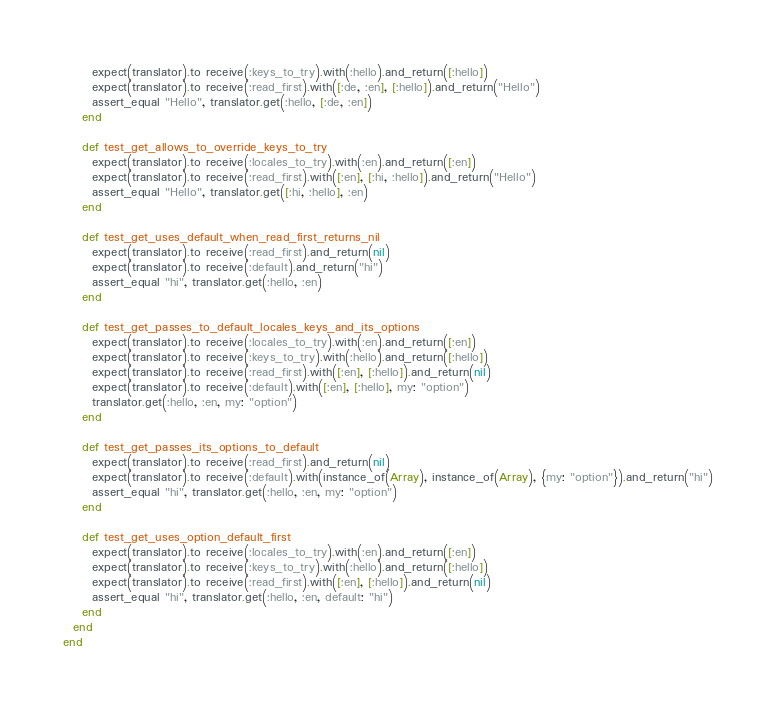<code> <loc_0><loc_0><loc_500><loc_500><_Ruby_>      expect(translator).to receive(:keys_to_try).with(:hello).and_return([:hello])
      expect(translator).to receive(:read_first).with([:de, :en], [:hello]).and_return("Hello")
      assert_equal "Hello", translator.get(:hello, [:de, :en])
    end

    def test_get_allows_to_override_keys_to_try
      expect(translator).to receive(:locales_to_try).with(:en).and_return([:en])
      expect(translator).to receive(:read_first).with([:en], [:hi, :hello]).and_return("Hello")
      assert_equal "Hello", translator.get([:hi, :hello], :en)
    end

    def test_get_uses_default_when_read_first_returns_nil
      expect(translator).to receive(:read_first).and_return(nil)
      expect(translator).to receive(:default).and_return("hi")
      assert_equal "hi", translator.get(:hello, :en)
    end

    def test_get_passes_to_default_locales_keys_and_its_options
      expect(translator).to receive(:locales_to_try).with(:en).and_return([:en])
      expect(translator).to receive(:keys_to_try).with(:hello).and_return([:hello])
      expect(translator).to receive(:read_first).with([:en], [:hello]).and_return(nil)
      expect(translator).to receive(:default).with([:en], [:hello], my: "option")
      translator.get(:hello, :en, my: "option")
    end

    def test_get_passes_its_options_to_default
      expect(translator).to receive(:read_first).and_return(nil)
      expect(translator).to receive(:default).with(instance_of(Array), instance_of(Array), {my: "option"}).and_return("hi")
      assert_equal "hi", translator.get(:hello, :en, my: "option")
    end

    def test_get_uses_option_default_first
      expect(translator).to receive(:locales_to_try).with(:en).and_return([:en])
      expect(translator).to receive(:keys_to_try).with(:hello).and_return([:hello])
      expect(translator).to receive(:read_first).with([:en], [:hello]).and_return(nil)
      assert_equal "hi", translator.get(:hello, :en, default: "hi")
    end
  end
end
</code> 